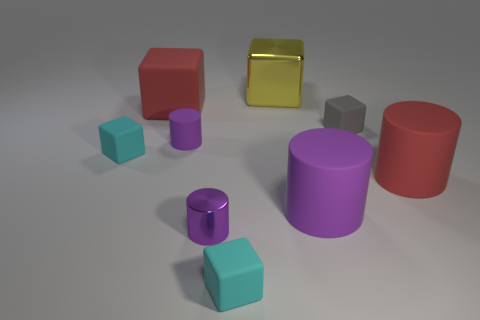Is the size of the red rubber cube that is behind the large red cylinder the same as the purple matte cylinder that is left of the small metal object?
Keep it short and to the point. No. What is the shape of the large rubber object that is to the left of the large purple cylinder?
Your answer should be very brief. Cube. What color is the tiny metal thing?
Provide a short and direct response. Purple. There is a red matte block; is it the same size as the cyan object to the right of the small purple metal object?
Ensure brevity in your answer.  No. What number of metallic objects are either green cylinders or big yellow objects?
Offer a very short reply. 1. Does the metallic cylinder have the same color as the small cylinder behind the large purple matte thing?
Provide a short and direct response. Yes. What is the shape of the gray matte object?
Offer a very short reply. Cube. What is the size of the purple metallic thing on the left side of the purple matte object that is in front of the red thing in front of the big red block?
Offer a terse response. Small. How many other things are the same shape as the large purple object?
Give a very brief answer. 3. There is a red rubber object that is to the left of the large yellow shiny cube; does it have the same shape as the large red matte object that is in front of the gray matte object?
Your answer should be compact. No. 